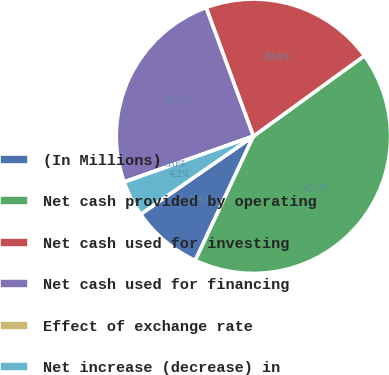Convert chart. <chart><loc_0><loc_0><loc_500><loc_500><pie_chart><fcel>(In Millions)<fcel>Net cash provided by operating<fcel>Net cash used for investing<fcel>Net cash used for financing<fcel>Effect of exchange rate<fcel>Net increase (decrease) in<nl><fcel>8.4%<fcel>41.96%<fcel>20.62%<fcel>24.81%<fcel>0.01%<fcel>4.2%<nl></chart> 